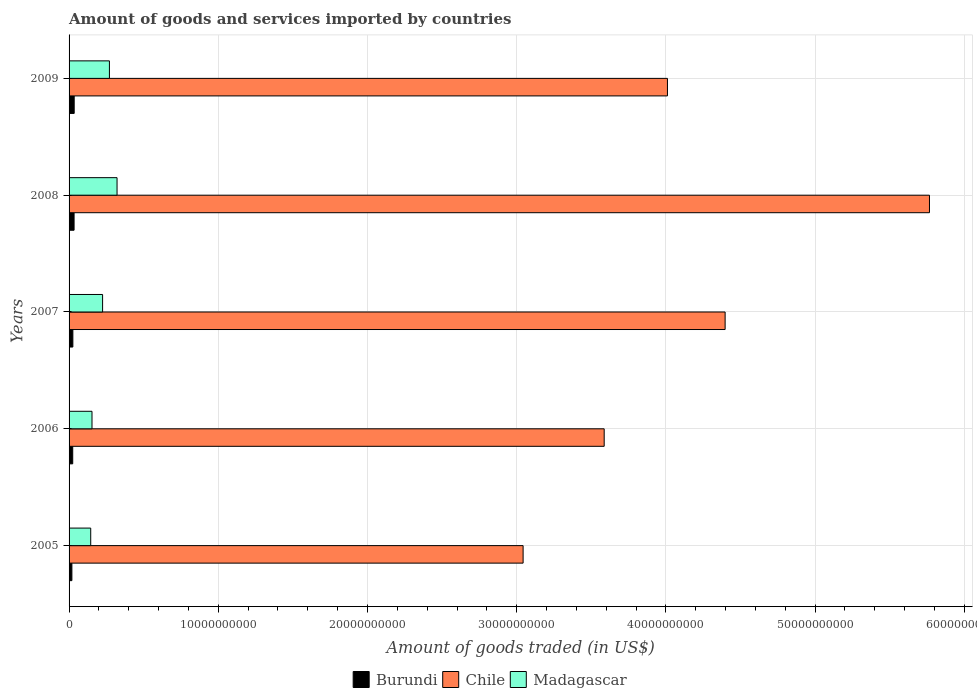How many different coloured bars are there?
Offer a terse response. 3. Are the number of bars on each tick of the Y-axis equal?
Provide a succinct answer. Yes. How many bars are there on the 1st tick from the bottom?
Give a very brief answer. 3. What is the label of the 2nd group of bars from the top?
Keep it short and to the point. 2008. In how many cases, is the number of bars for a given year not equal to the number of legend labels?
Offer a very short reply. 0. What is the total amount of goods and services imported in Burundi in 2009?
Provide a succinct answer. 3.43e+08. Across all years, what is the maximum total amount of goods and services imported in Madagascar?
Ensure brevity in your answer.  3.22e+09. Across all years, what is the minimum total amount of goods and services imported in Chile?
Your answer should be very brief. 3.04e+1. In which year was the total amount of goods and services imported in Burundi maximum?
Provide a succinct answer. 2009. What is the total total amount of goods and services imported in Madagascar in the graph?
Your response must be concise. 1.12e+1. What is the difference between the total amount of goods and services imported in Madagascar in 2007 and that in 2009?
Your response must be concise. -4.57e+08. What is the difference between the total amount of goods and services imported in Chile in 2006 and the total amount of goods and services imported in Burundi in 2009?
Offer a very short reply. 3.55e+1. What is the average total amount of goods and services imported in Madagascar per year?
Make the answer very short. 2.23e+09. In the year 2009, what is the difference between the total amount of goods and services imported in Chile and total amount of goods and services imported in Burundi?
Make the answer very short. 3.98e+1. What is the ratio of the total amount of goods and services imported in Chile in 2006 to that in 2007?
Give a very brief answer. 0.82. Is the total amount of goods and services imported in Chile in 2007 less than that in 2009?
Your answer should be compact. No. Is the difference between the total amount of goods and services imported in Chile in 2007 and 2009 greater than the difference between the total amount of goods and services imported in Burundi in 2007 and 2009?
Your answer should be compact. Yes. What is the difference between the highest and the second highest total amount of goods and services imported in Burundi?
Offer a very short reply. 7.56e+06. What is the difference between the highest and the lowest total amount of goods and services imported in Chile?
Your response must be concise. 2.72e+1. In how many years, is the total amount of goods and services imported in Chile greater than the average total amount of goods and services imported in Chile taken over all years?
Offer a terse response. 2. Is the sum of the total amount of goods and services imported in Madagascar in 2007 and 2009 greater than the maximum total amount of goods and services imported in Burundi across all years?
Offer a terse response. Yes. What does the 1st bar from the top in 2005 represents?
Make the answer very short. Madagascar. What does the 3rd bar from the bottom in 2009 represents?
Provide a succinct answer. Madagascar. Is it the case that in every year, the sum of the total amount of goods and services imported in Burundi and total amount of goods and services imported in Chile is greater than the total amount of goods and services imported in Madagascar?
Make the answer very short. Yes. How many bars are there?
Ensure brevity in your answer.  15. Does the graph contain any zero values?
Provide a short and direct response. No. Does the graph contain grids?
Give a very brief answer. Yes. How many legend labels are there?
Provide a short and direct response. 3. What is the title of the graph?
Your answer should be compact. Amount of goods and services imported by countries. Does "South Africa" appear as one of the legend labels in the graph?
Your response must be concise. No. What is the label or title of the X-axis?
Your answer should be compact. Amount of goods traded (in US$). What is the label or title of the Y-axis?
Provide a succinct answer. Years. What is the Amount of goods traded (in US$) in Burundi in 2005?
Give a very brief answer. 1.89e+08. What is the Amount of goods traded (in US$) in Chile in 2005?
Make the answer very short. 3.04e+1. What is the Amount of goods traded (in US$) in Madagascar in 2005?
Ensure brevity in your answer.  1.45e+09. What is the Amount of goods traded (in US$) in Burundi in 2006?
Your answer should be compact. 2.45e+08. What is the Amount of goods traded (in US$) of Chile in 2006?
Keep it short and to the point. 3.59e+1. What is the Amount of goods traded (in US$) in Madagascar in 2006?
Provide a succinct answer. 1.54e+09. What is the Amount of goods traded (in US$) of Burundi in 2007?
Provide a short and direct response. 2.54e+08. What is the Amount of goods traded (in US$) of Chile in 2007?
Your answer should be very brief. 4.40e+1. What is the Amount of goods traded (in US$) of Madagascar in 2007?
Your response must be concise. 2.25e+09. What is the Amount of goods traded (in US$) in Burundi in 2008?
Your answer should be very brief. 3.35e+08. What is the Amount of goods traded (in US$) of Chile in 2008?
Ensure brevity in your answer.  5.77e+1. What is the Amount of goods traded (in US$) in Madagascar in 2008?
Offer a very short reply. 3.22e+09. What is the Amount of goods traded (in US$) in Burundi in 2009?
Keep it short and to the point. 3.43e+08. What is the Amount of goods traded (in US$) in Chile in 2009?
Provide a short and direct response. 4.01e+1. What is the Amount of goods traded (in US$) of Madagascar in 2009?
Offer a terse response. 2.70e+09. Across all years, what is the maximum Amount of goods traded (in US$) of Burundi?
Make the answer very short. 3.43e+08. Across all years, what is the maximum Amount of goods traded (in US$) in Chile?
Offer a very short reply. 5.77e+1. Across all years, what is the maximum Amount of goods traded (in US$) of Madagascar?
Your answer should be very brief. 3.22e+09. Across all years, what is the minimum Amount of goods traded (in US$) of Burundi?
Your response must be concise. 1.89e+08. Across all years, what is the minimum Amount of goods traded (in US$) in Chile?
Your answer should be very brief. 3.04e+1. Across all years, what is the minimum Amount of goods traded (in US$) in Madagascar?
Keep it short and to the point. 1.45e+09. What is the total Amount of goods traded (in US$) of Burundi in the graph?
Provide a short and direct response. 1.37e+09. What is the total Amount of goods traded (in US$) of Chile in the graph?
Your answer should be very brief. 2.08e+11. What is the total Amount of goods traded (in US$) of Madagascar in the graph?
Make the answer very short. 1.12e+1. What is the difference between the Amount of goods traded (in US$) of Burundi in 2005 and that in 2006?
Make the answer very short. -5.58e+07. What is the difference between the Amount of goods traded (in US$) of Chile in 2005 and that in 2006?
Offer a very short reply. -5.43e+09. What is the difference between the Amount of goods traded (in US$) in Madagascar in 2005 and that in 2006?
Offer a very short reply. -8.52e+07. What is the difference between the Amount of goods traded (in US$) of Burundi in 2005 and that in 2007?
Your answer should be compact. -6.52e+07. What is the difference between the Amount of goods traded (in US$) of Chile in 2005 and that in 2007?
Your answer should be compact. -1.35e+1. What is the difference between the Amount of goods traded (in US$) in Madagascar in 2005 and that in 2007?
Make the answer very short. -7.96e+08. What is the difference between the Amount of goods traded (in US$) of Burundi in 2005 and that in 2008?
Make the answer very short. -1.47e+08. What is the difference between the Amount of goods traded (in US$) in Chile in 2005 and that in 2008?
Your answer should be compact. -2.72e+1. What is the difference between the Amount of goods traded (in US$) in Madagascar in 2005 and that in 2008?
Make the answer very short. -1.76e+09. What is the difference between the Amount of goods traded (in US$) in Burundi in 2005 and that in 2009?
Your response must be concise. -1.54e+08. What is the difference between the Amount of goods traded (in US$) of Chile in 2005 and that in 2009?
Make the answer very short. -9.67e+09. What is the difference between the Amount of goods traded (in US$) in Madagascar in 2005 and that in 2009?
Ensure brevity in your answer.  -1.25e+09. What is the difference between the Amount of goods traded (in US$) of Burundi in 2006 and that in 2007?
Provide a succinct answer. -9.42e+06. What is the difference between the Amount of goods traded (in US$) in Chile in 2006 and that in 2007?
Offer a very short reply. -8.10e+09. What is the difference between the Amount of goods traded (in US$) of Madagascar in 2006 and that in 2007?
Your response must be concise. -7.11e+08. What is the difference between the Amount of goods traded (in US$) of Burundi in 2006 and that in 2008?
Your response must be concise. -9.08e+07. What is the difference between the Amount of goods traded (in US$) of Chile in 2006 and that in 2008?
Provide a short and direct response. -2.18e+1. What is the difference between the Amount of goods traded (in US$) of Madagascar in 2006 and that in 2008?
Your response must be concise. -1.68e+09. What is the difference between the Amount of goods traded (in US$) in Burundi in 2006 and that in 2009?
Keep it short and to the point. -9.83e+07. What is the difference between the Amount of goods traded (in US$) of Chile in 2006 and that in 2009?
Your answer should be very brief. -4.24e+09. What is the difference between the Amount of goods traded (in US$) of Madagascar in 2006 and that in 2009?
Provide a short and direct response. -1.17e+09. What is the difference between the Amount of goods traded (in US$) of Burundi in 2007 and that in 2008?
Your answer should be very brief. -8.13e+07. What is the difference between the Amount of goods traded (in US$) in Chile in 2007 and that in 2008?
Offer a terse response. -1.37e+1. What is the difference between the Amount of goods traded (in US$) in Madagascar in 2007 and that in 2008?
Ensure brevity in your answer.  -9.69e+08. What is the difference between the Amount of goods traded (in US$) of Burundi in 2007 and that in 2009?
Offer a terse response. -8.89e+07. What is the difference between the Amount of goods traded (in US$) of Chile in 2007 and that in 2009?
Provide a short and direct response. 3.87e+09. What is the difference between the Amount of goods traded (in US$) of Madagascar in 2007 and that in 2009?
Provide a short and direct response. -4.57e+08. What is the difference between the Amount of goods traded (in US$) in Burundi in 2008 and that in 2009?
Your answer should be compact. -7.56e+06. What is the difference between the Amount of goods traded (in US$) of Chile in 2008 and that in 2009?
Provide a succinct answer. 1.76e+1. What is the difference between the Amount of goods traded (in US$) of Madagascar in 2008 and that in 2009?
Offer a terse response. 5.11e+08. What is the difference between the Amount of goods traded (in US$) of Burundi in 2005 and the Amount of goods traded (in US$) of Chile in 2006?
Keep it short and to the point. -3.57e+1. What is the difference between the Amount of goods traded (in US$) of Burundi in 2005 and the Amount of goods traded (in US$) of Madagascar in 2006?
Give a very brief answer. -1.35e+09. What is the difference between the Amount of goods traded (in US$) in Chile in 2005 and the Amount of goods traded (in US$) in Madagascar in 2006?
Provide a short and direct response. 2.89e+1. What is the difference between the Amount of goods traded (in US$) of Burundi in 2005 and the Amount of goods traded (in US$) of Chile in 2007?
Your answer should be very brief. -4.38e+1. What is the difference between the Amount of goods traded (in US$) in Burundi in 2005 and the Amount of goods traded (in US$) in Madagascar in 2007?
Offer a terse response. -2.06e+09. What is the difference between the Amount of goods traded (in US$) of Chile in 2005 and the Amount of goods traded (in US$) of Madagascar in 2007?
Give a very brief answer. 2.82e+1. What is the difference between the Amount of goods traded (in US$) of Burundi in 2005 and the Amount of goods traded (in US$) of Chile in 2008?
Offer a very short reply. -5.75e+1. What is the difference between the Amount of goods traded (in US$) of Burundi in 2005 and the Amount of goods traded (in US$) of Madagascar in 2008?
Make the answer very short. -3.03e+09. What is the difference between the Amount of goods traded (in US$) in Chile in 2005 and the Amount of goods traded (in US$) in Madagascar in 2008?
Offer a very short reply. 2.72e+1. What is the difference between the Amount of goods traded (in US$) of Burundi in 2005 and the Amount of goods traded (in US$) of Chile in 2009?
Give a very brief answer. -3.99e+1. What is the difference between the Amount of goods traded (in US$) in Burundi in 2005 and the Amount of goods traded (in US$) in Madagascar in 2009?
Provide a succinct answer. -2.52e+09. What is the difference between the Amount of goods traded (in US$) of Chile in 2005 and the Amount of goods traded (in US$) of Madagascar in 2009?
Your response must be concise. 2.77e+1. What is the difference between the Amount of goods traded (in US$) in Burundi in 2006 and the Amount of goods traded (in US$) in Chile in 2007?
Provide a short and direct response. -4.37e+1. What is the difference between the Amount of goods traded (in US$) in Burundi in 2006 and the Amount of goods traded (in US$) in Madagascar in 2007?
Make the answer very short. -2.00e+09. What is the difference between the Amount of goods traded (in US$) in Chile in 2006 and the Amount of goods traded (in US$) in Madagascar in 2007?
Your response must be concise. 3.36e+1. What is the difference between the Amount of goods traded (in US$) of Burundi in 2006 and the Amount of goods traded (in US$) of Chile in 2008?
Offer a very short reply. -5.74e+1. What is the difference between the Amount of goods traded (in US$) of Burundi in 2006 and the Amount of goods traded (in US$) of Madagascar in 2008?
Ensure brevity in your answer.  -2.97e+09. What is the difference between the Amount of goods traded (in US$) of Chile in 2006 and the Amount of goods traded (in US$) of Madagascar in 2008?
Offer a very short reply. 3.26e+1. What is the difference between the Amount of goods traded (in US$) in Burundi in 2006 and the Amount of goods traded (in US$) in Chile in 2009?
Keep it short and to the point. -3.99e+1. What is the difference between the Amount of goods traded (in US$) in Burundi in 2006 and the Amount of goods traded (in US$) in Madagascar in 2009?
Make the answer very short. -2.46e+09. What is the difference between the Amount of goods traded (in US$) in Chile in 2006 and the Amount of goods traded (in US$) in Madagascar in 2009?
Your answer should be compact. 3.32e+1. What is the difference between the Amount of goods traded (in US$) in Burundi in 2007 and the Amount of goods traded (in US$) in Chile in 2008?
Keep it short and to the point. -5.74e+1. What is the difference between the Amount of goods traded (in US$) in Burundi in 2007 and the Amount of goods traded (in US$) in Madagascar in 2008?
Offer a very short reply. -2.96e+09. What is the difference between the Amount of goods traded (in US$) in Chile in 2007 and the Amount of goods traded (in US$) in Madagascar in 2008?
Provide a short and direct response. 4.08e+1. What is the difference between the Amount of goods traded (in US$) in Burundi in 2007 and the Amount of goods traded (in US$) in Chile in 2009?
Provide a succinct answer. -3.98e+1. What is the difference between the Amount of goods traded (in US$) of Burundi in 2007 and the Amount of goods traded (in US$) of Madagascar in 2009?
Provide a short and direct response. -2.45e+09. What is the difference between the Amount of goods traded (in US$) in Chile in 2007 and the Amount of goods traded (in US$) in Madagascar in 2009?
Make the answer very short. 4.13e+1. What is the difference between the Amount of goods traded (in US$) of Burundi in 2008 and the Amount of goods traded (in US$) of Chile in 2009?
Offer a very short reply. -3.98e+1. What is the difference between the Amount of goods traded (in US$) of Burundi in 2008 and the Amount of goods traded (in US$) of Madagascar in 2009?
Keep it short and to the point. -2.37e+09. What is the difference between the Amount of goods traded (in US$) of Chile in 2008 and the Amount of goods traded (in US$) of Madagascar in 2009?
Offer a very short reply. 5.50e+1. What is the average Amount of goods traded (in US$) of Burundi per year?
Your response must be concise. 2.73e+08. What is the average Amount of goods traded (in US$) of Chile per year?
Offer a very short reply. 4.16e+1. What is the average Amount of goods traded (in US$) of Madagascar per year?
Ensure brevity in your answer.  2.23e+09. In the year 2005, what is the difference between the Amount of goods traded (in US$) of Burundi and Amount of goods traded (in US$) of Chile?
Your answer should be compact. -3.02e+1. In the year 2005, what is the difference between the Amount of goods traded (in US$) in Burundi and Amount of goods traded (in US$) in Madagascar?
Make the answer very short. -1.26e+09. In the year 2005, what is the difference between the Amount of goods traded (in US$) of Chile and Amount of goods traded (in US$) of Madagascar?
Ensure brevity in your answer.  2.90e+1. In the year 2006, what is the difference between the Amount of goods traded (in US$) of Burundi and Amount of goods traded (in US$) of Chile?
Keep it short and to the point. -3.56e+1. In the year 2006, what is the difference between the Amount of goods traded (in US$) of Burundi and Amount of goods traded (in US$) of Madagascar?
Offer a terse response. -1.29e+09. In the year 2006, what is the difference between the Amount of goods traded (in US$) of Chile and Amount of goods traded (in US$) of Madagascar?
Provide a succinct answer. 3.43e+1. In the year 2007, what is the difference between the Amount of goods traded (in US$) of Burundi and Amount of goods traded (in US$) of Chile?
Offer a very short reply. -4.37e+1. In the year 2007, what is the difference between the Amount of goods traded (in US$) in Burundi and Amount of goods traded (in US$) in Madagascar?
Offer a very short reply. -1.99e+09. In the year 2007, what is the difference between the Amount of goods traded (in US$) in Chile and Amount of goods traded (in US$) in Madagascar?
Provide a short and direct response. 4.17e+1. In the year 2008, what is the difference between the Amount of goods traded (in US$) in Burundi and Amount of goods traded (in US$) in Chile?
Offer a terse response. -5.73e+1. In the year 2008, what is the difference between the Amount of goods traded (in US$) of Burundi and Amount of goods traded (in US$) of Madagascar?
Ensure brevity in your answer.  -2.88e+09. In the year 2008, what is the difference between the Amount of goods traded (in US$) of Chile and Amount of goods traded (in US$) of Madagascar?
Provide a short and direct response. 5.44e+1. In the year 2009, what is the difference between the Amount of goods traded (in US$) in Burundi and Amount of goods traded (in US$) in Chile?
Ensure brevity in your answer.  -3.98e+1. In the year 2009, what is the difference between the Amount of goods traded (in US$) of Burundi and Amount of goods traded (in US$) of Madagascar?
Make the answer very short. -2.36e+09. In the year 2009, what is the difference between the Amount of goods traded (in US$) of Chile and Amount of goods traded (in US$) of Madagascar?
Keep it short and to the point. 3.74e+1. What is the ratio of the Amount of goods traded (in US$) in Burundi in 2005 to that in 2006?
Provide a short and direct response. 0.77. What is the ratio of the Amount of goods traded (in US$) in Chile in 2005 to that in 2006?
Offer a terse response. 0.85. What is the ratio of the Amount of goods traded (in US$) in Madagascar in 2005 to that in 2006?
Your answer should be compact. 0.94. What is the ratio of the Amount of goods traded (in US$) in Burundi in 2005 to that in 2007?
Keep it short and to the point. 0.74. What is the ratio of the Amount of goods traded (in US$) in Chile in 2005 to that in 2007?
Keep it short and to the point. 0.69. What is the ratio of the Amount of goods traded (in US$) of Madagascar in 2005 to that in 2007?
Offer a terse response. 0.65. What is the ratio of the Amount of goods traded (in US$) of Burundi in 2005 to that in 2008?
Your response must be concise. 0.56. What is the ratio of the Amount of goods traded (in US$) of Chile in 2005 to that in 2008?
Your answer should be compact. 0.53. What is the ratio of the Amount of goods traded (in US$) of Madagascar in 2005 to that in 2008?
Keep it short and to the point. 0.45. What is the ratio of the Amount of goods traded (in US$) of Burundi in 2005 to that in 2009?
Your answer should be compact. 0.55. What is the ratio of the Amount of goods traded (in US$) of Chile in 2005 to that in 2009?
Offer a very short reply. 0.76. What is the ratio of the Amount of goods traded (in US$) in Madagascar in 2005 to that in 2009?
Your answer should be compact. 0.54. What is the ratio of the Amount of goods traded (in US$) in Burundi in 2006 to that in 2007?
Offer a terse response. 0.96. What is the ratio of the Amount of goods traded (in US$) of Chile in 2006 to that in 2007?
Make the answer very short. 0.82. What is the ratio of the Amount of goods traded (in US$) in Madagascar in 2006 to that in 2007?
Your response must be concise. 0.68. What is the ratio of the Amount of goods traded (in US$) in Burundi in 2006 to that in 2008?
Make the answer very short. 0.73. What is the ratio of the Amount of goods traded (in US$) in Chile in 2006 to that in 2008?
Offer a very short reply. 0.62. What is the ratio of the Amount of goods traded (in US$) of Madagascar in 2006 to that in 2008?
Your response must be concise. 0.48. What is the ratio of the Amount of goods traded (in US$) in Burundi in 2006 to that in 2009?
Keep it short and to the point. 0.71. What is the ratio of the Amount of goods traded (in US$) of Chile in 2006 to that in 2009?
Your answer should be compact. 0.89. What is the ratio of the Amount of goods traded (in US$) of Madagascar in 2006 to that in 2009?
Provide a short and direct response. 0.57. What is the ratio of the Amount of goods traded (in US$) in Burundi in 2007 to that in 2008?
Give a very brief answer. 0.76. What is the ratio of the Amount of goods traded (in US$) of Chile in 2007 to that in 2008?
Your response must be concise. 0.76. What is the ratio of the Amount of goods traded (in US$) in Madagascar in 2007 to that in 2008?
Your answer should be compact. 0.7. What is the ratio of the Amount of goods traded (in US$) in Burundi in 2007 to that in 2009?
Offer a terse response. 0.74. What is the ratio of the Amount of goods traded (in US$) of Chile in 2007 to that in 2009?
Ensure brevity in your answer.  1.1. What is the ratio of the Amount of goods traded (in US$) of Madagascar in 2007 to that in 2009?
Your response must be concise. 0.83. What is the ratio of the Amount of goods traded (in US$) in Burundi in 2008 to that in 2009?
Offer a terse response. 0.98. What is the ratio of the Amount of goods traded (in US$) of Chile in 2008 to that in 2009?
Provide a short and direct response. 1.44. What is the ratio of the Amount of goods traded (in US$) in Madagascar in 2008 to that in 2009?
Ensure brevity in your answer.  1.19. What is the difference between the highest and the second highest Amount of goods traded (in US$) in Burundi?
Give a very brief answer. 7.56e+06. What is the difference between the highest and the second highest Amount of goods traded (in US$) in Chile?
Ensure brevity in your answer.  1.37e+1. What is the difference between the highest and the second highest Amount of goods traded (in US$) in Madagascar?
Your answer should be very brief. 5.11e+08. What is the difference between the highest and the lowest Amount of goods traded (in US$) of Burundi?
Make the answer very short. 1.54e+08. What is the difference between the highest and the lowest Amount of goods traded (in US$) of Chile?
Your answer should be very brief. 2.72e+1. What is the difference between the highest and the lowest Amount of goods traded (in US$) of Madagascar?
Keep it short and to the point. 1.76e+09. 